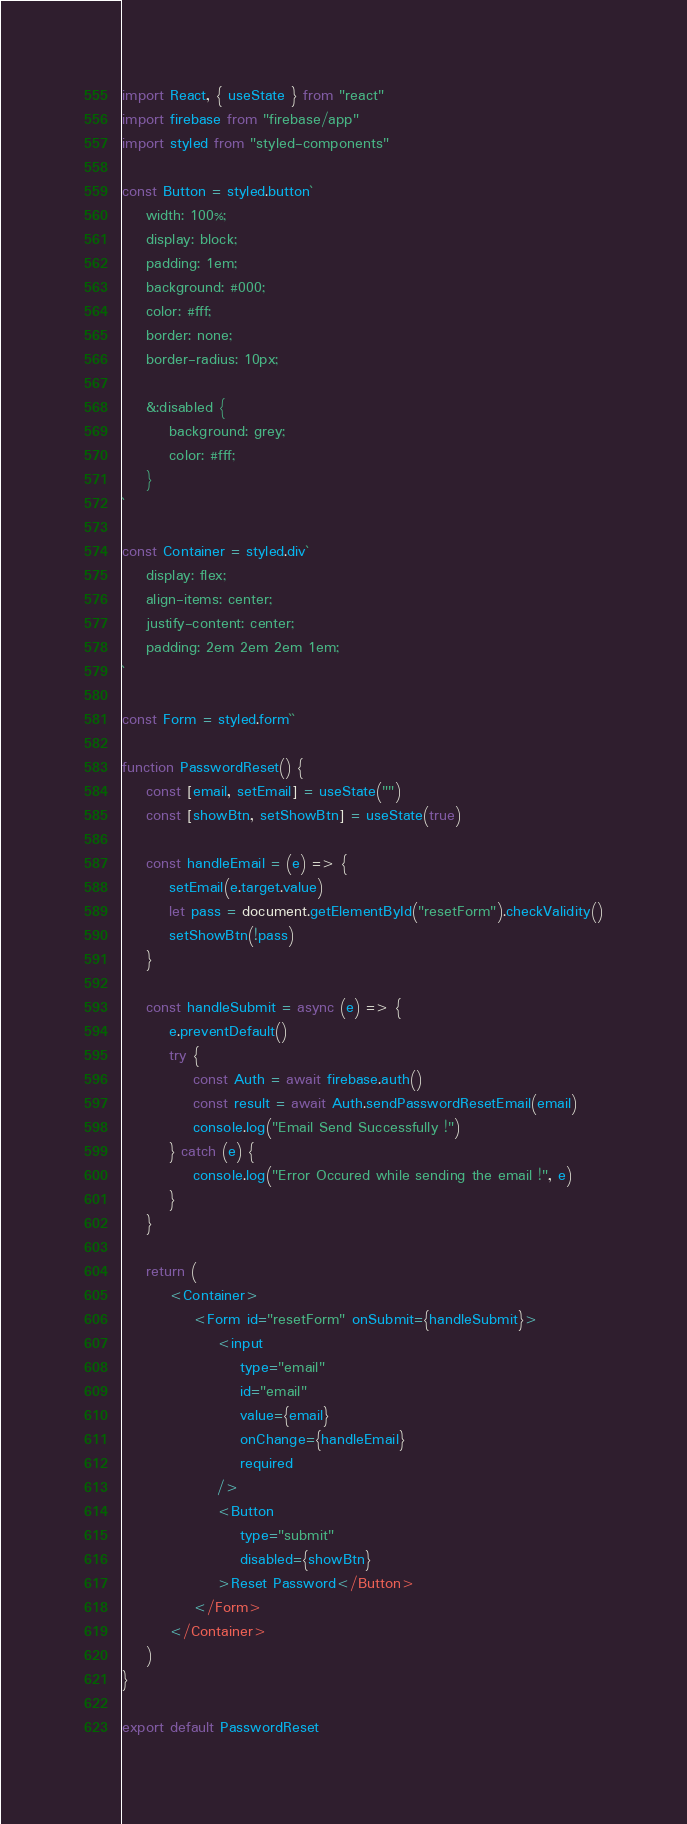<code> <loc_0><loc_0><loc_500><loc_500><_JavaScript_>import React, { useState } from "react"
import firebase from "firebase/app"
import styled from "styled-components"

const Button = styled.button`
    width: 100%;
    display: block;
    padding: 1em;
    background: #000;
    color: #fff;
    border: none;
    border-radius: 10px;

    &:disabled {
        background: grey;
        color: #fff;
    }
`

const Container = styled.div`
    display: flex;
    align-items: center;
    justify-content: center;
    padding: 2em 2em 2em 1em;
`

const Form = styled.form``

function PasswordReset() {
    const [email, setEmail] = useState("")
    const [showBtn, setShowBtn] = useState(true)

    const handleEmail = (e) => {
        setEmail(e.target.value)
        let pass = document.getElementById("resetForm").checkValidity()
        setShowBtn(!pass)
    }

    const handleSubmit = async (e) => {
        e.preventDefault()
        try {
            const Auth = await firebase.auth()
            const result = await Auth.sendPasswordResetEmail(email)
            console.log("Email Send Successfully !")
        } catch (e) {
            console.log("Error Occured while sending the email !", e)
        }
    }

    return (
        <Container>
            <Form id="resetForm" onSubmit={handleSubmit}>
                <input
                    type="email"
                    id="email"
                    value={email}
                    onChange={handleEmail}
                    required
                />
                <Button
                    type="submit"
                    disabled={showBtn}
                >Reset Password</Button>
            </Form>
        </Container>
    )
}

export default PasswordReset
</code> 